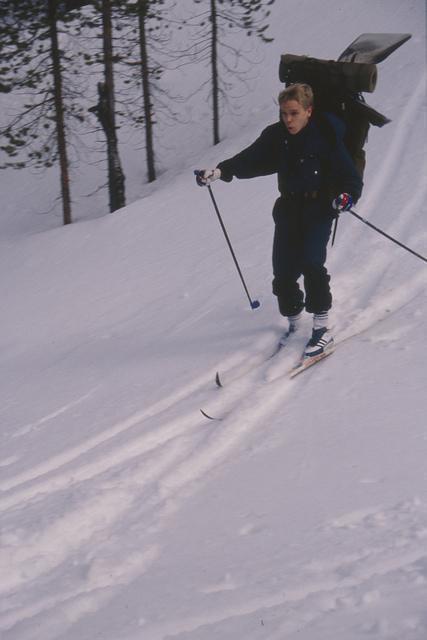What is the shovel carried here meant to be used for first?
Pick the correct solution from the four options below to address the question.
Options: Signaling, grave digging, snow removal, coal. Snow removal. 